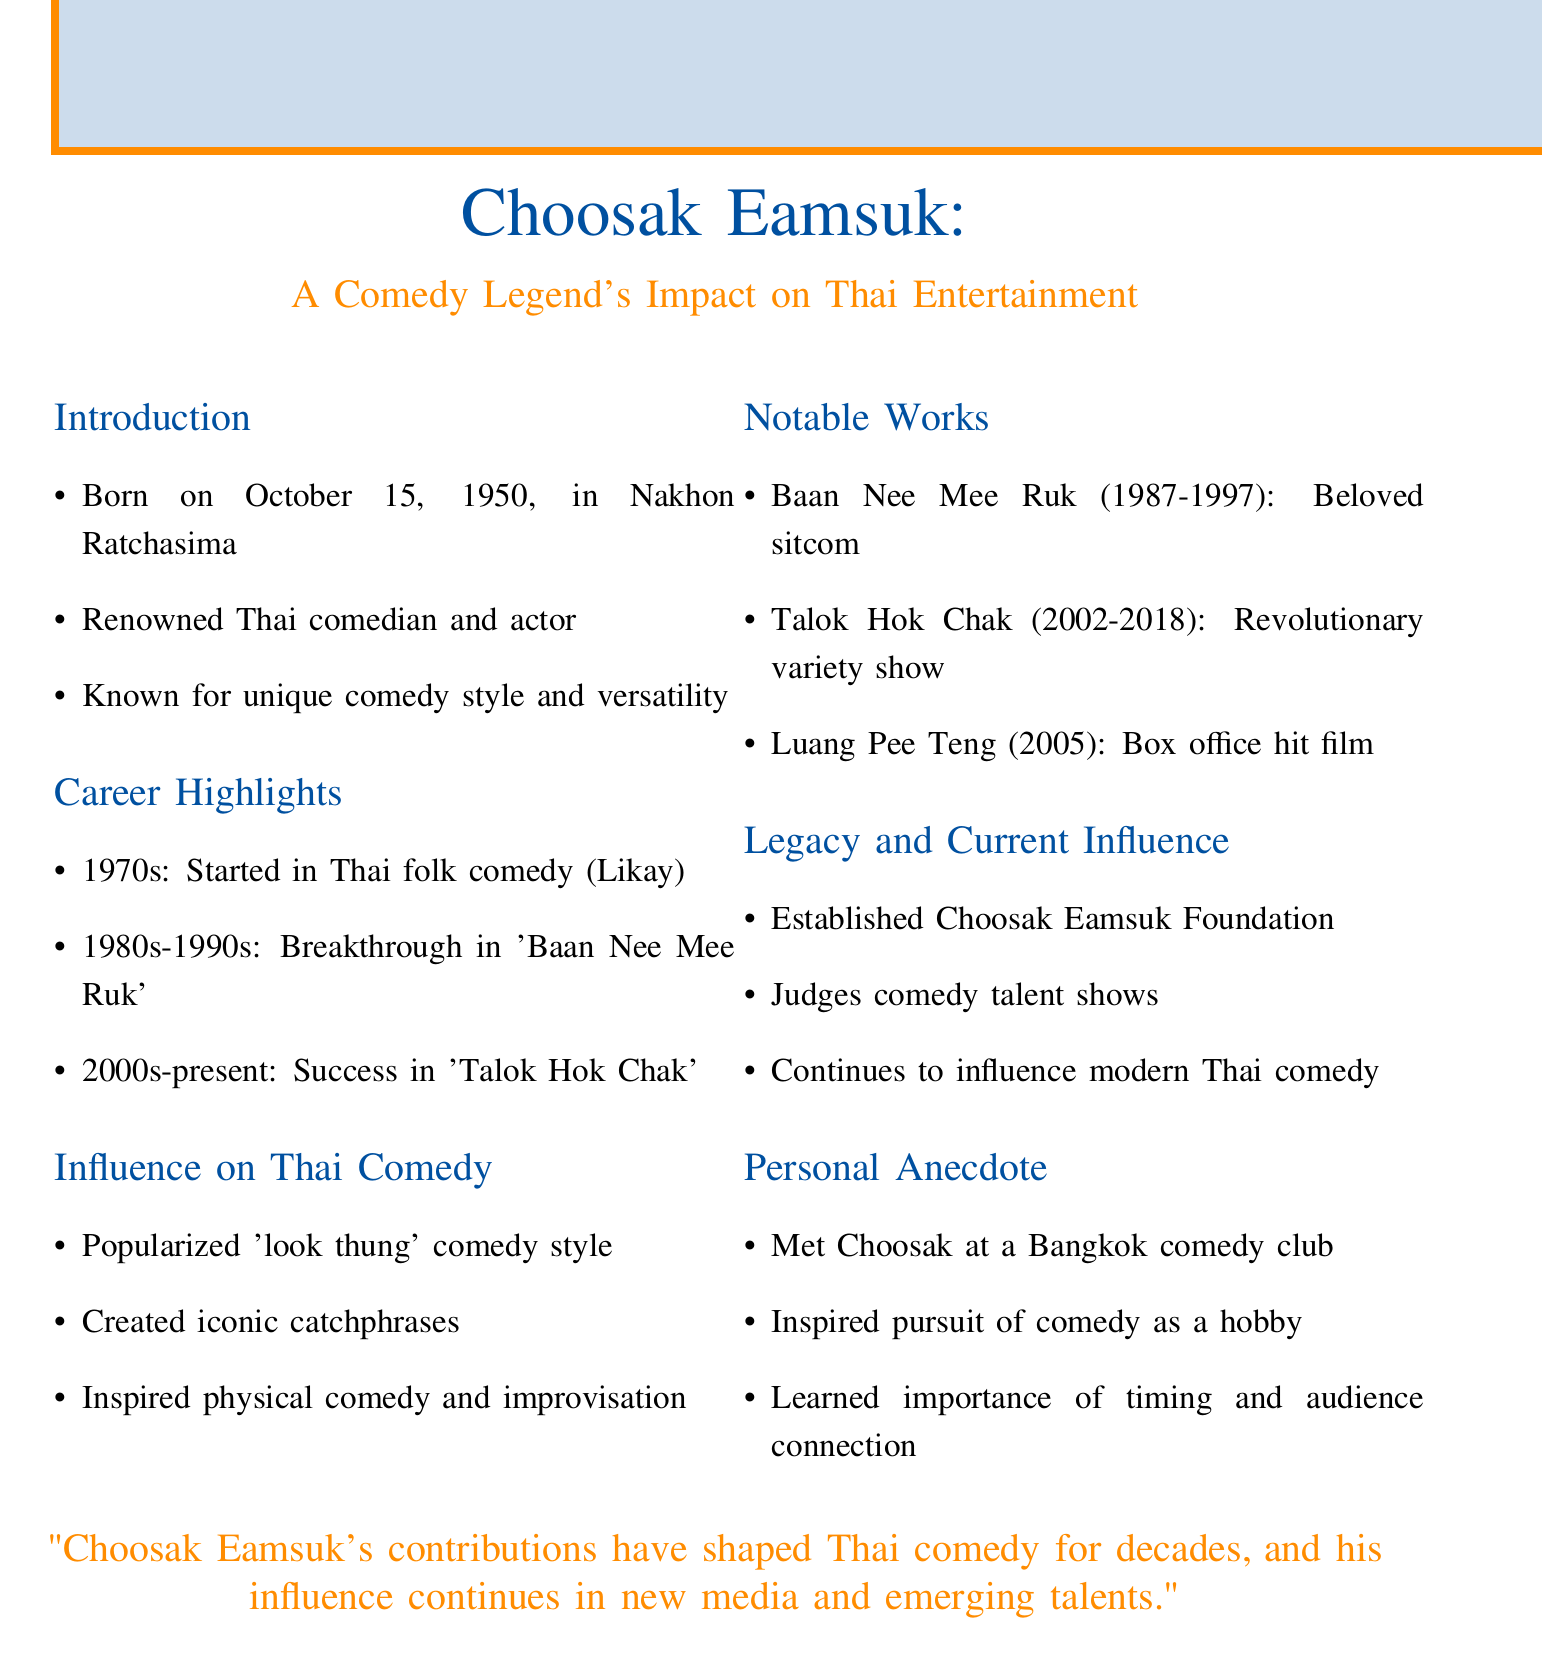What is Choosak Eamsuk's date of birth? He was born on October 15, 1950.
Answer: October 15, 1950 What type of comedy did Choosak Eamsuk start his career in? He started his career in Thai folk comedy, known as Likay.
Answer: Likay What is the title of Choosak's breakthrough sitcom? The breakthrough sitcom is "Baan Nee Mee Ruk."
Answer: Baan Nee Mee Ruk In which year did Choosak receive a lifetime achievement award? He received the award in 2015 at the Suphannahong National Film Awards.
Answer: 2015 How long did "Baan Nee Mee Ruk" run? The sitcom ran from 1987 to 1997.
Answer: 1987-1997 What comedy style did Choosak popularize? He popularized the 'look thung' comedy style.
Answer: look thung Which film revitalized the comedy genre in Thailand? The film "Luang Pee Teng" became a box office hit and revitalized the genre.
Answer: Luang Pee Teng What foundation did Choosak establish? He established the Choosak Eamsuk Foundation to support aspiring comedians.
Answer: Choosak Eamsuk Foundation Which talent show does Choosak regularly judge? He is a regular judge on "Thailand's Got Talent."
Answer: Thailand's Got Talent 